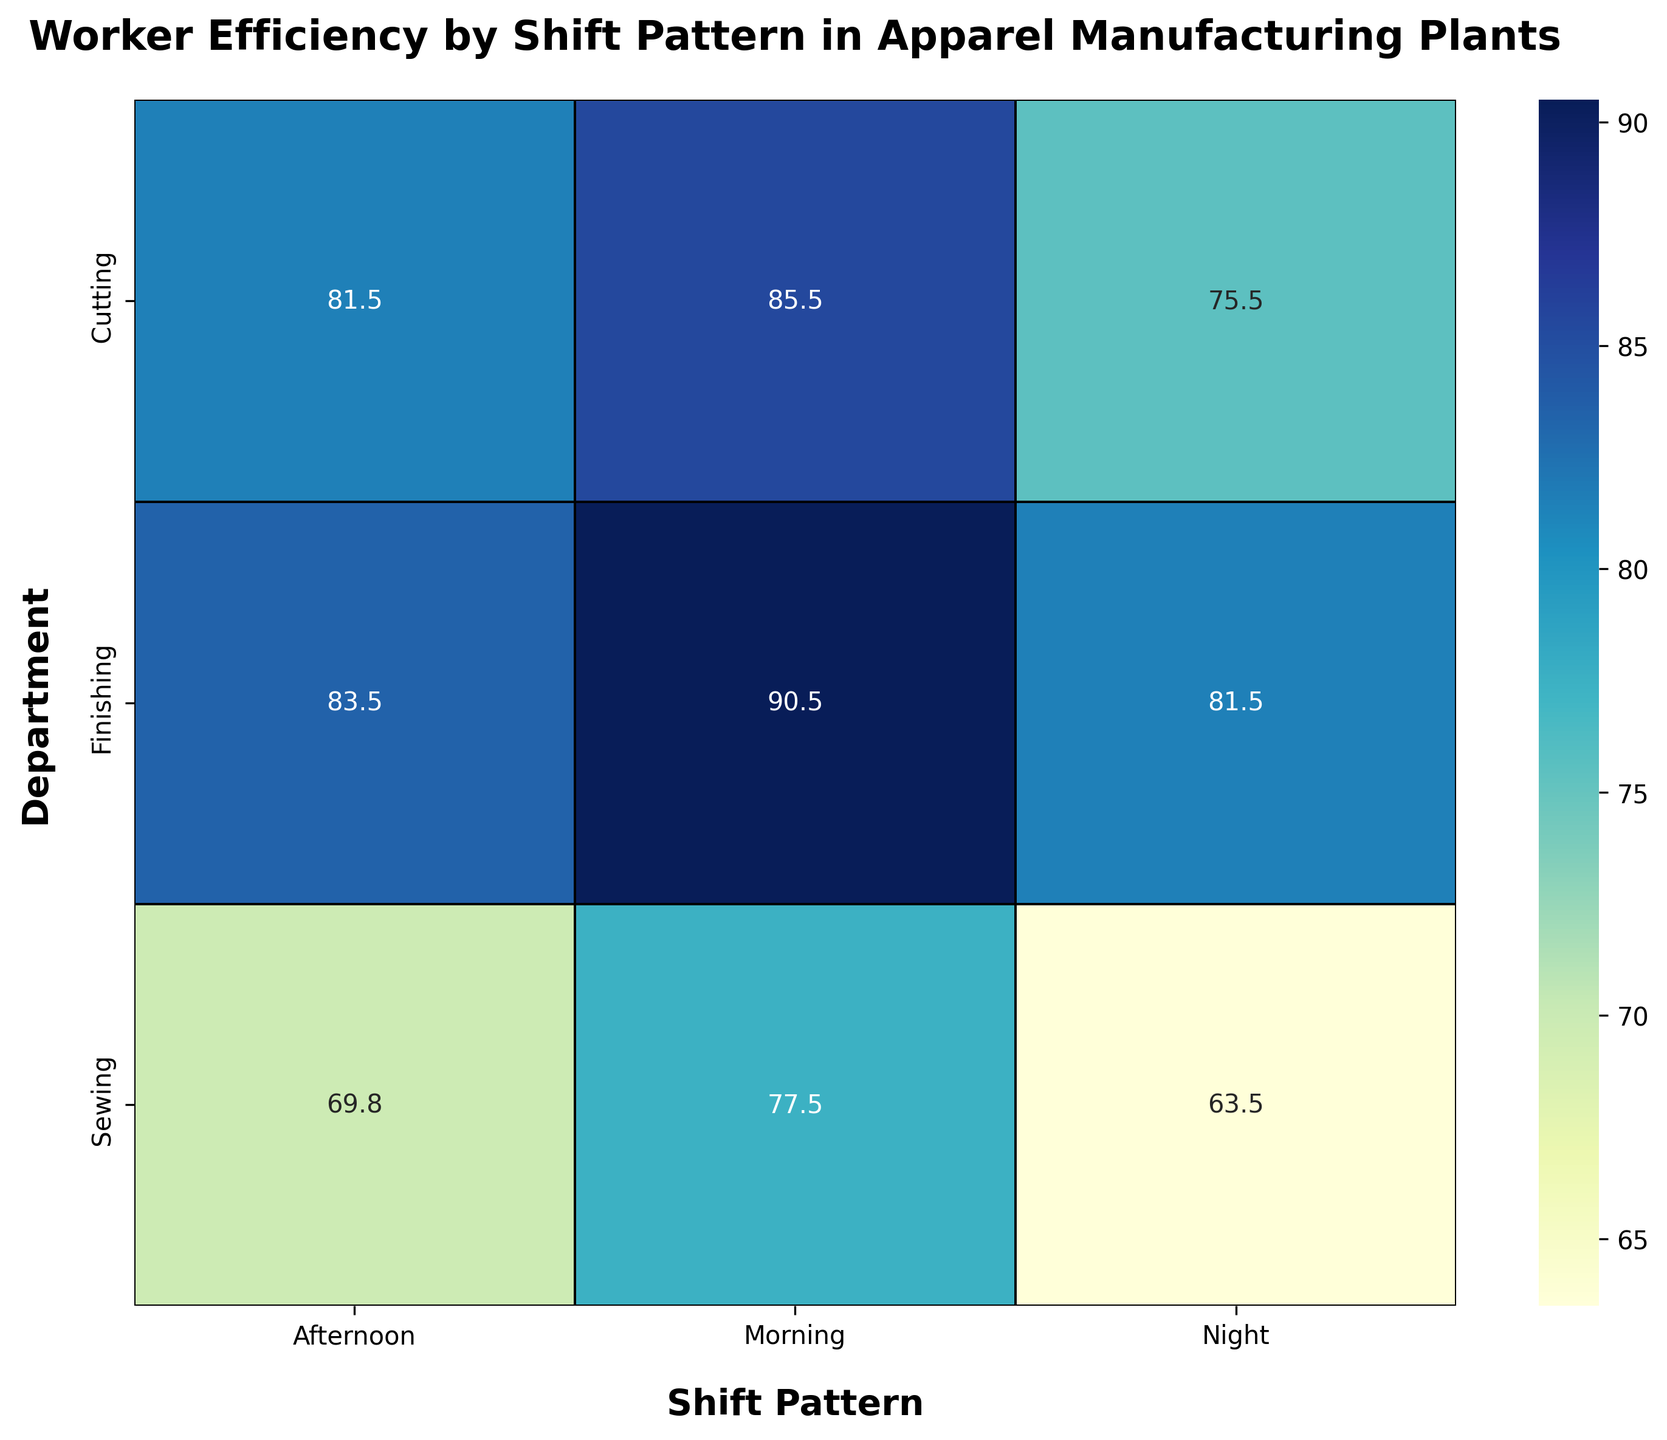What's the highest worker efficiency in the Morning shift for the Cutting department? The figure shows the heatmap where the Morning shift for the Cutting department is highlighted. By looking at the Morning column under Cutting, we can see the maximum value.
Answer: 88 Which shift pattern shows the lowest worker efficiency for the Sewing department? By examining the Sewing row across all shift patterns in the heatmap, we identify the minimum value.
Answer: Night How does the average efficiency in the Finishing department during the Afternoon shift compare to the efficiency during the Morning shift? Calculate the average efficiency from the Finishing department during the Afternoon and compare it to the Morning shift. The Afternoon shows values of 82, 84, 83, and 85, so the average is (82+84+83+85)/4 = 83.5. The Morning values are 90, 92, 89, and 91, so the average is (90+92+89+91)/4 = 90.5.
Answer: Afternoon is less efficient What is the overall trend in worker efficiency from Morning to Night shift patterns in the Cutting department? Observing the Cutting row, the heatmap values for efficiency decrease from Morning to Night shifts, representing a downward trend.
Answer: Decreasing Which department maintains the highest consistency in worker efficiency across all shifts? By comparing the color shades and efficiency values across each department, it's clear that the Finishing department shows relatively consistent worker efficiency (`Morning`: ~90.5, `Afternoon`: ~83.5, `Night`: ~81.5).
Answer: Finishing What’s the average efficiency across all departments during the afternoon shift? Calculate the average values shown in the Afternoon column: Cutting (81.5), Sewing (69.75), Finishing (83.5). The computation is (81.5 + 69.75 + 83.5)/3 = 78.92.
Answer: 78.9 Between Morning and Night shifts, which one has a greater variance in efficiency in the Sewing department? Calculate the variance for Morning (75, 78, 80, 77) and Night (62, 65, 64, 63). Variance is higher when values are more spread out. Variance for Morning = 6.25, Night = 1.67.
Answer: Morning 